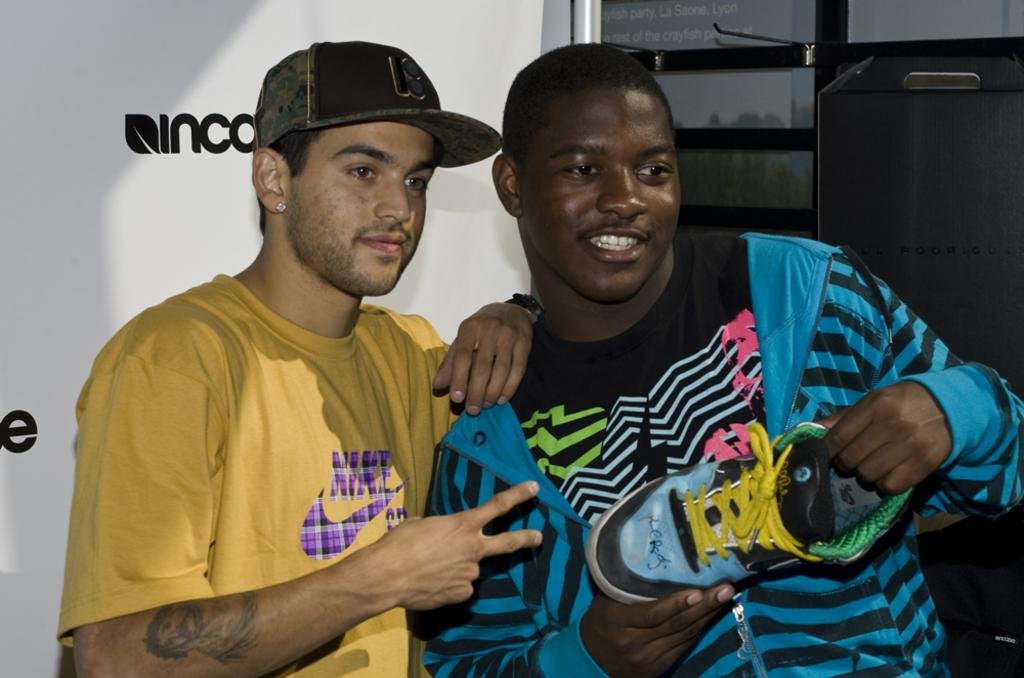<image>
Present a compact description of the photo's key features. a man with a NIke shirt posing with another one 